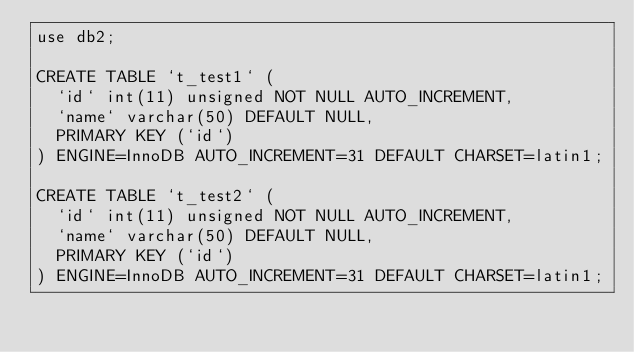Convert code to text. <code><loc_0><loc_0><loc_500><loc_500><_SQL_>use db2;

CREATE TABLE `t_test1` (
  `id` int(11) unsigned NOT NULL AUTO_INCREMENT,
  `name` varchar(50) DEFAULT NULL,
  PRIMARY KEY (`id`)
) ENGINE=InnoDB AUTO_INCREMENT=31 DEFAULT CHARSET=latin1;

CREATE TABLE `t_test2` (
  `id` int(11) unsigned NOT NULL AUTO_INCREMENT,
  `name` varchar(50) DEFAULT NULL,
  PRIMARY KEY (`id`)
) ENGINE=InnoDB AUTO_INCREMENT=31 DEFAULT CHARSET=latin1;
</code> 